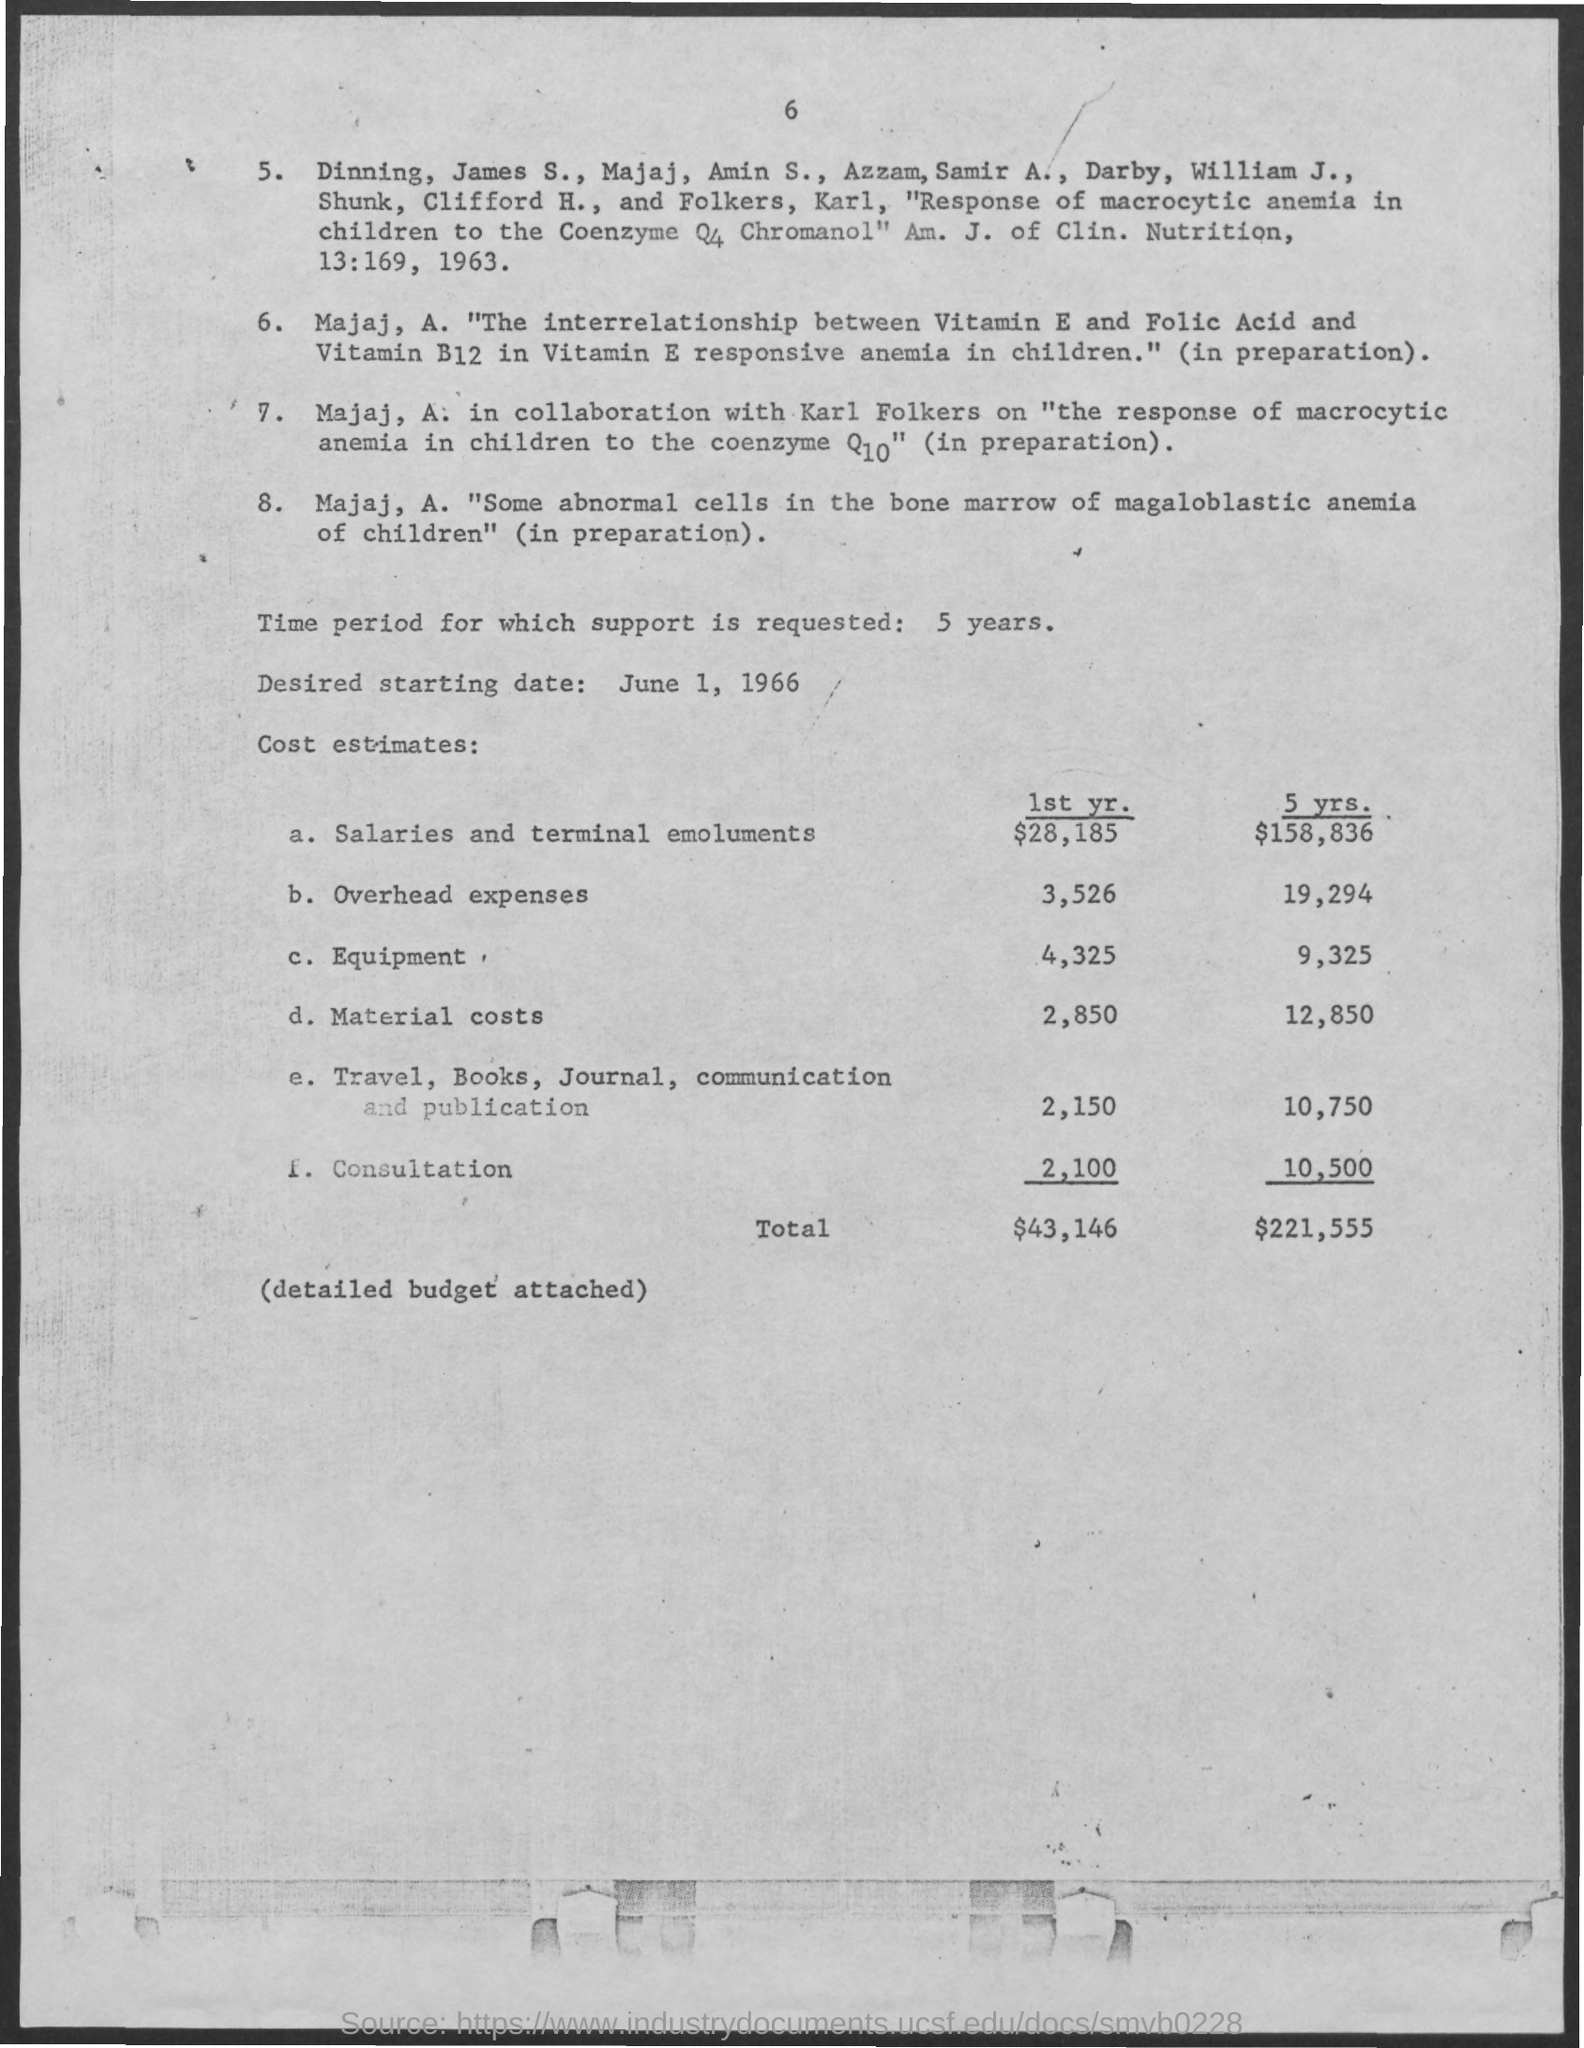What is the Time Period for which support is requested?
Your answer should be compact. 5 years. What is the Desired Start Date?
Make the answer very short. June 1, 1966. What is the Cost Estimate for Salaries and terminal emoluments for 1st Year?
Keep it short and to the point. $28,185. What is the Cost Estimate for Salaries and terminal emoluments for 5 Years?
Make the answer very short. $158,836. What is the Cost Estimate for Overhead Expenses for 1st Year?
Your response must be concise. 3,526. What is the Cost Estimate for Overhead Expenses for 5 Years?
Your answer should be very brief. 19,294. What is the Cost Estimate for Equipment for 1st Year?
Ensure brevity in your answer.  4,325. What is the Cost Estimate for Equipment for 5 Years?
Provide a succinct answer. 9,325. What is the Cost Estimate for Material costs for 1st Year?
Offer a terse response. 2,850. What is the Cost Estimate for Material costs for 5 Years?
Give a very brief answer. 12,850. 